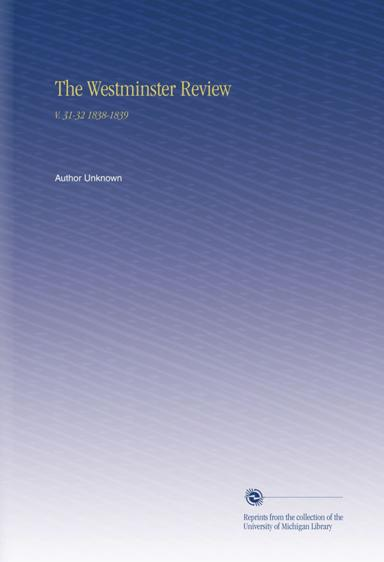Could you tell me more about the significance of 'The Westminster Review' during the years 1838 to 1839? 'The Westminster Review' was a prominent British publication in the 19th century, championing philosophical radicalism and fostering intellectual debate. During 1838 to 1839, it played a crucial role in discussing and influencing public opinion on matters such as social reform, scientific progress, and political theory. This period was rife with cultural and political transformation, making the Review a key voice in shaping contemporary thought. 